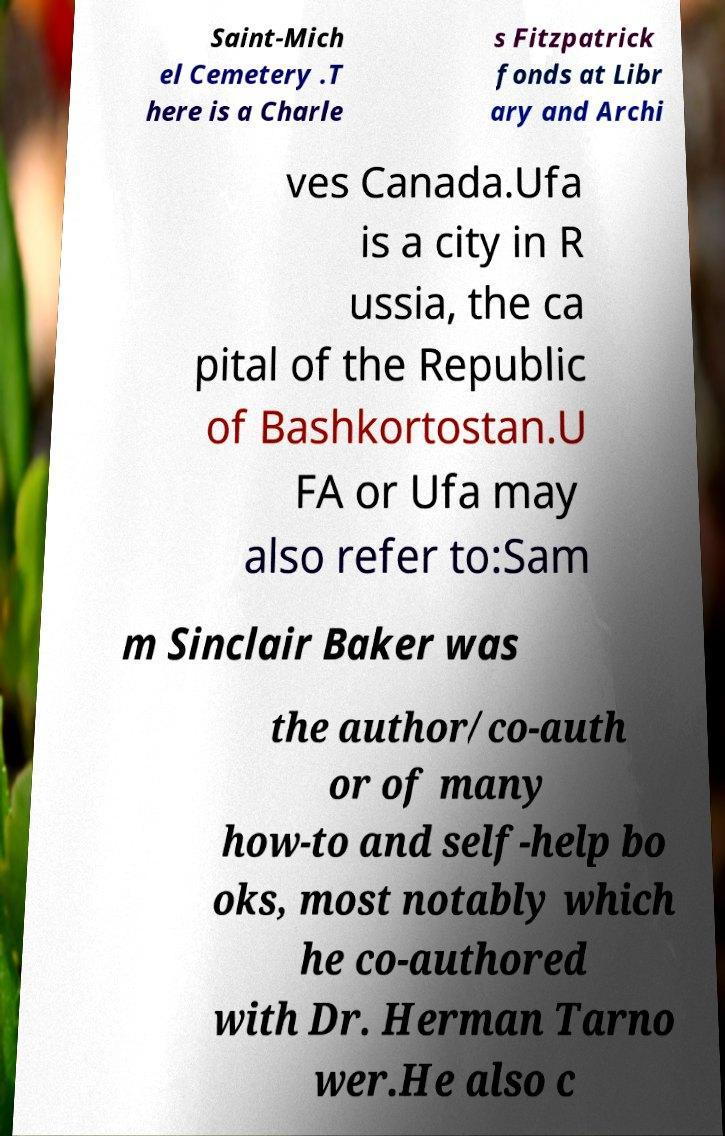I need the written content from this picture converted into text. Can you do that? Saint-Mich el Cemetery .T here is a Charle s Fitzpatrick fonds at Libr ary and Archi ves Canada.Ufa is a city in R ussia, the ca pital of the Republic of Bashkortostan.U FA or Ufa may also refer to:Sam m Sinclair Baker was the author/co-auth or of many how-to and self-help bo oks, most notably which he co-authored with Dr. Herman Tarno wer.He also c 